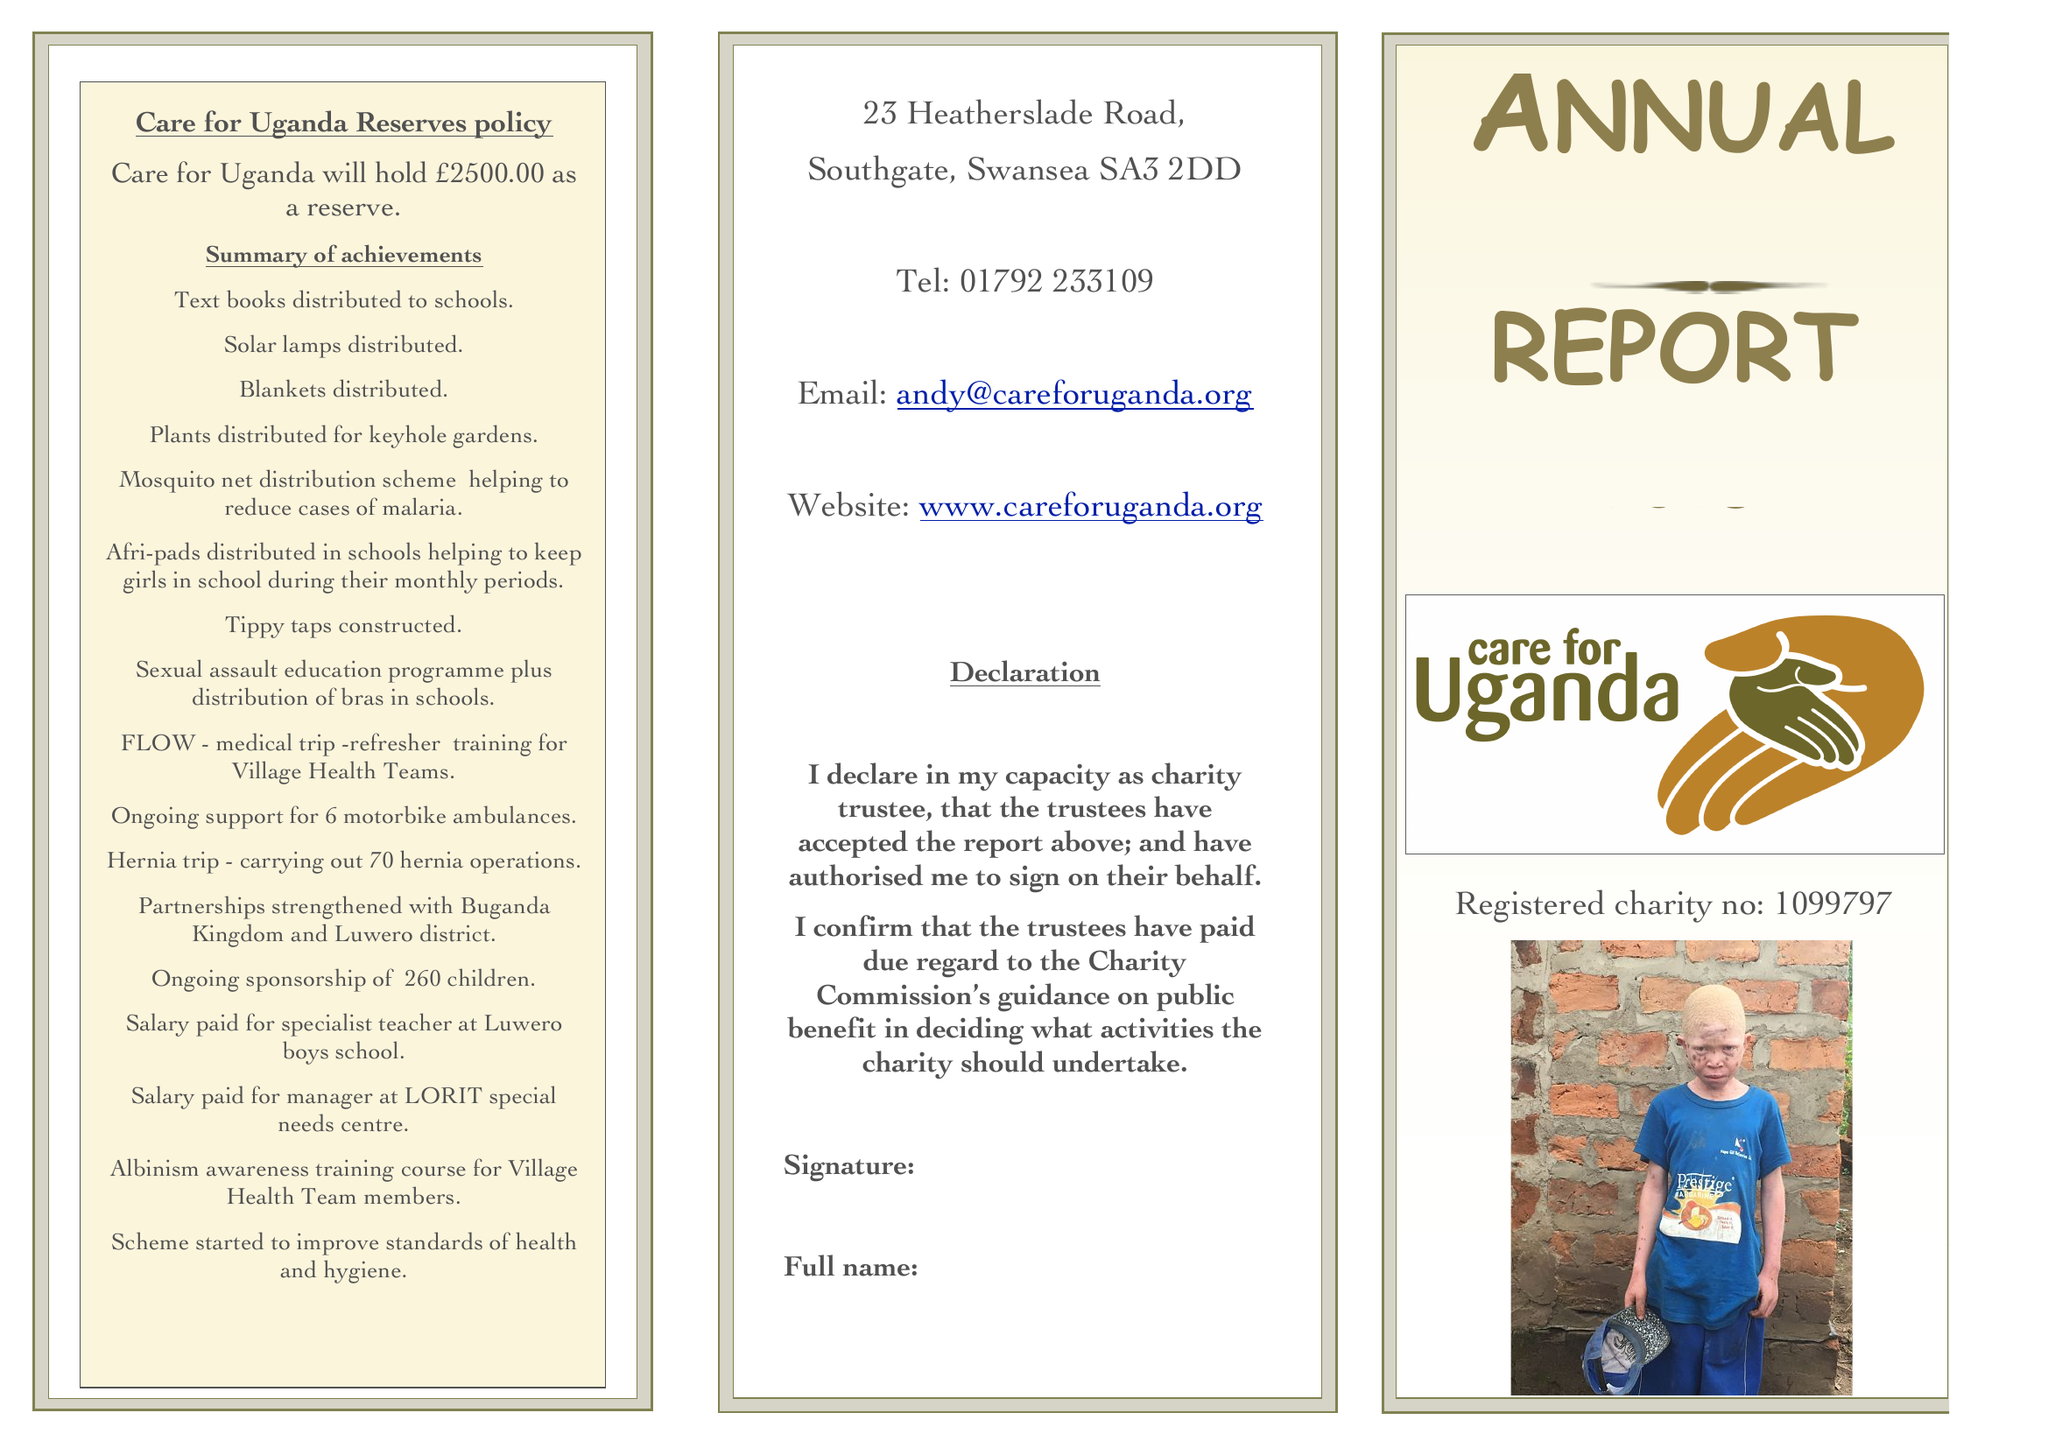What is the value for the report_date?
Answer the question using a single word or phrase. 2018-03-31 